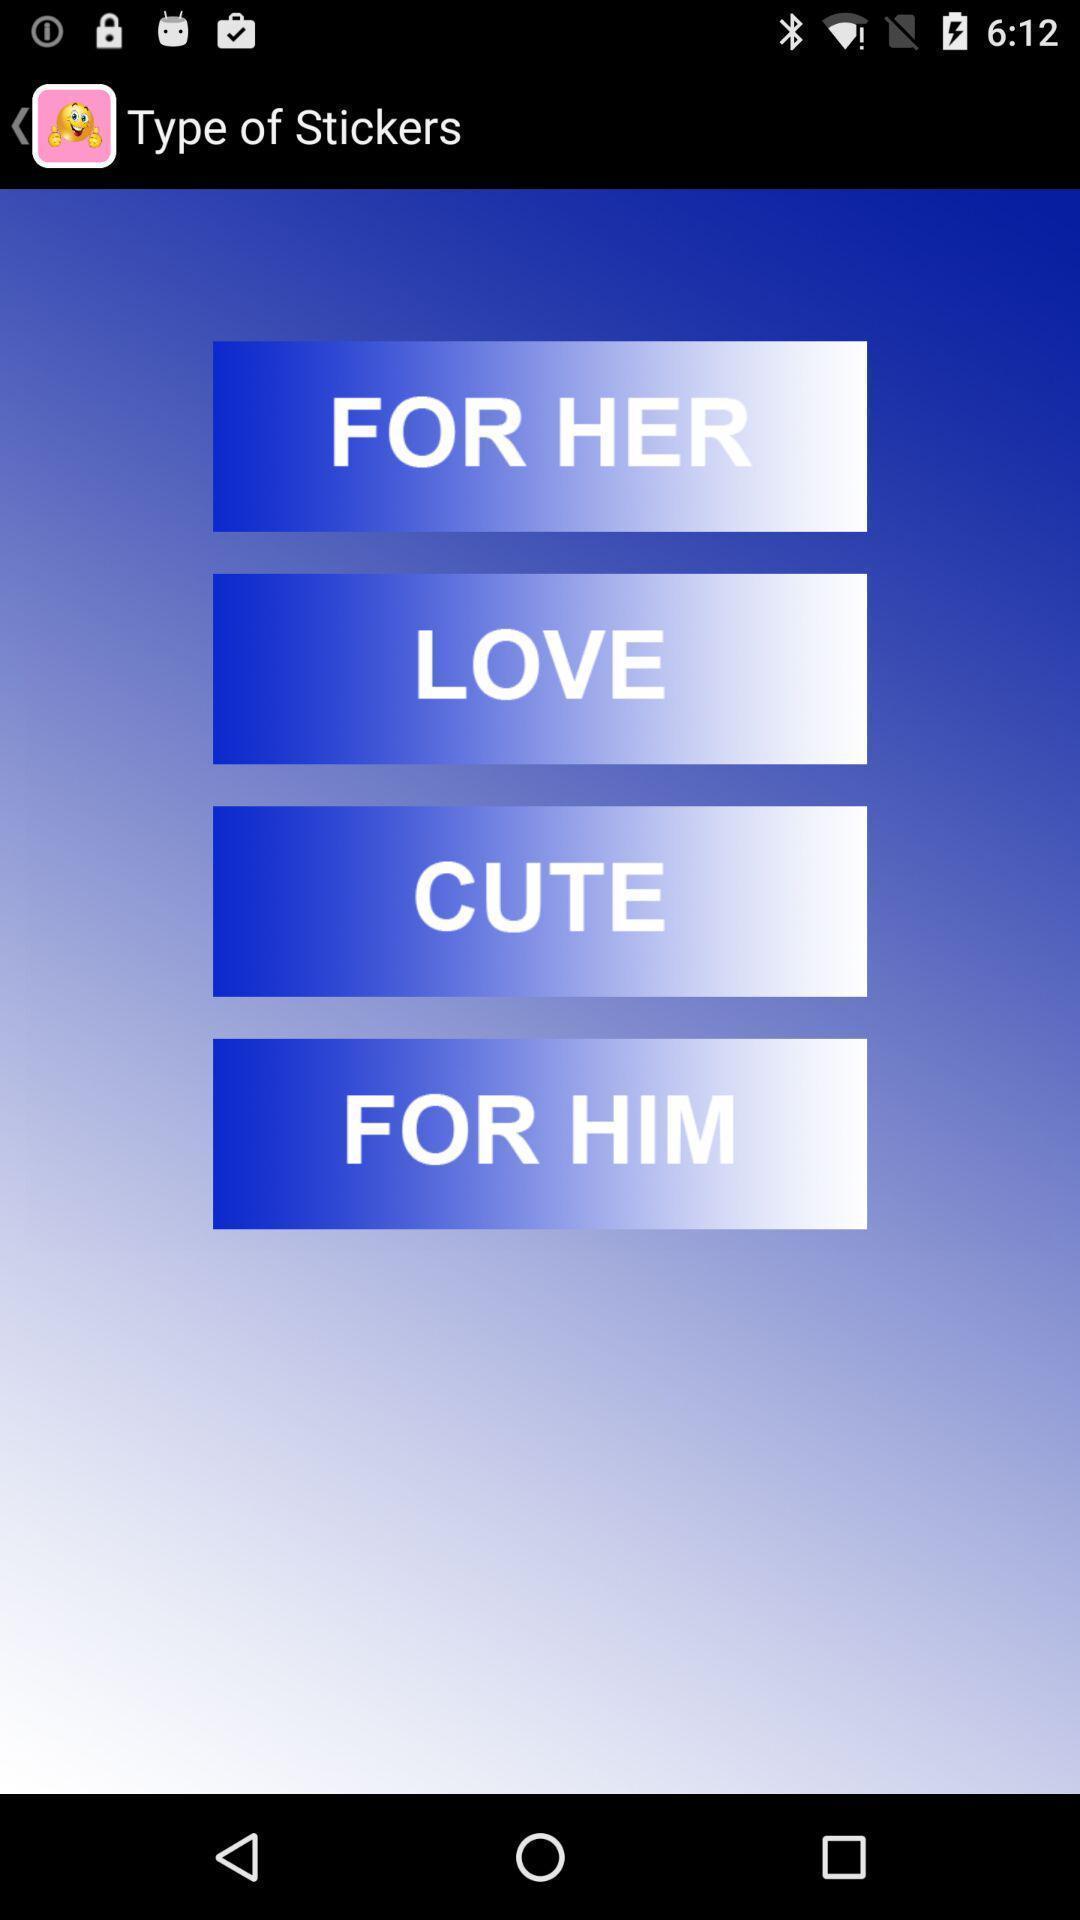Please provide a description for this image. Page showing list of various types of stickers. 